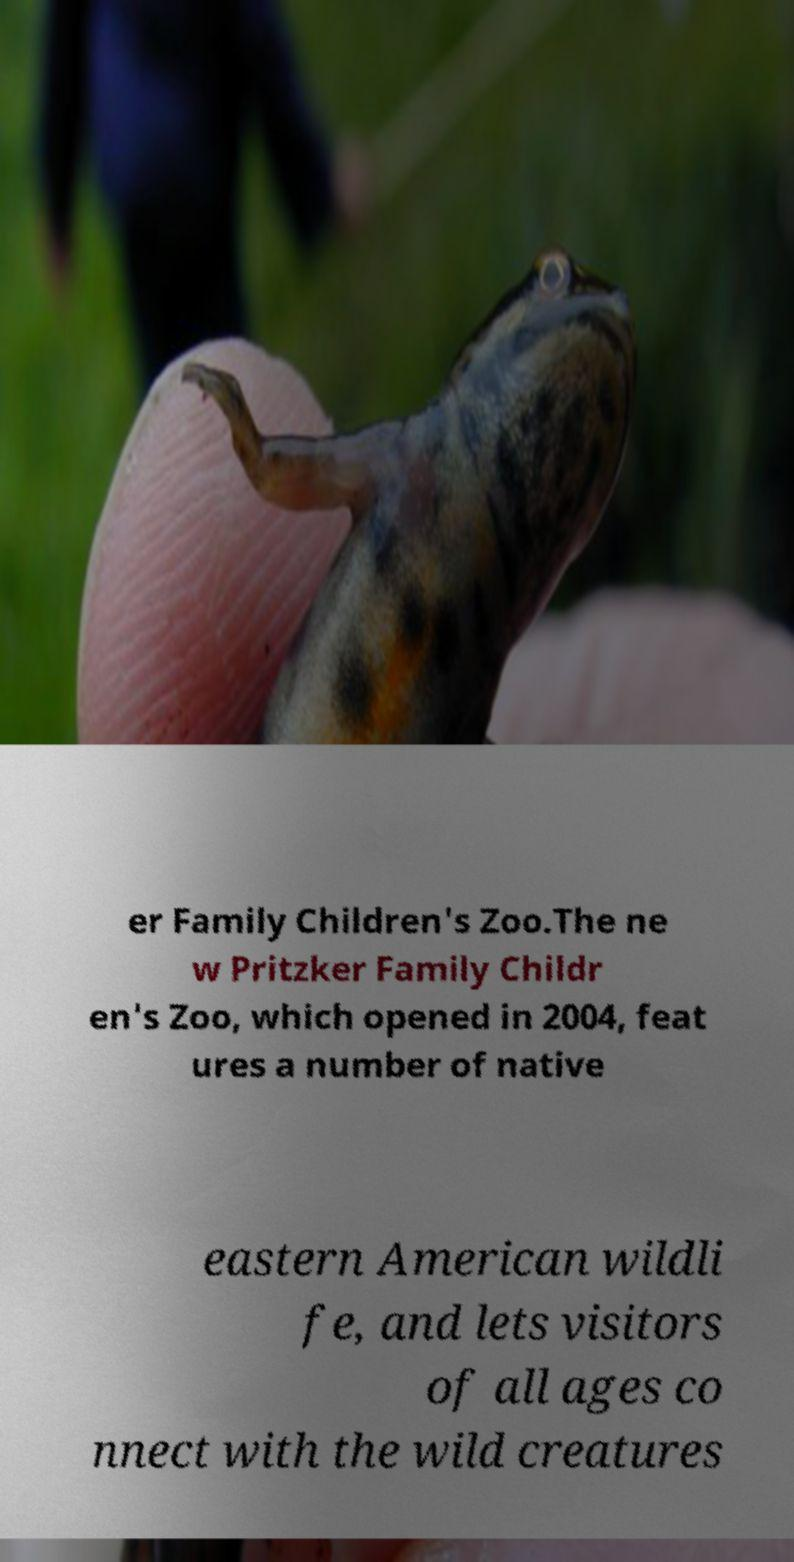Could you extract and type out the text from this image? er Family Children's Zoo.The ne w Pritzker Family Childr en's Zoo, which opened in 2004, feat ures a number of native eastern American wildli fe, and lets visitors of all ages co nnect with the wild creatures 